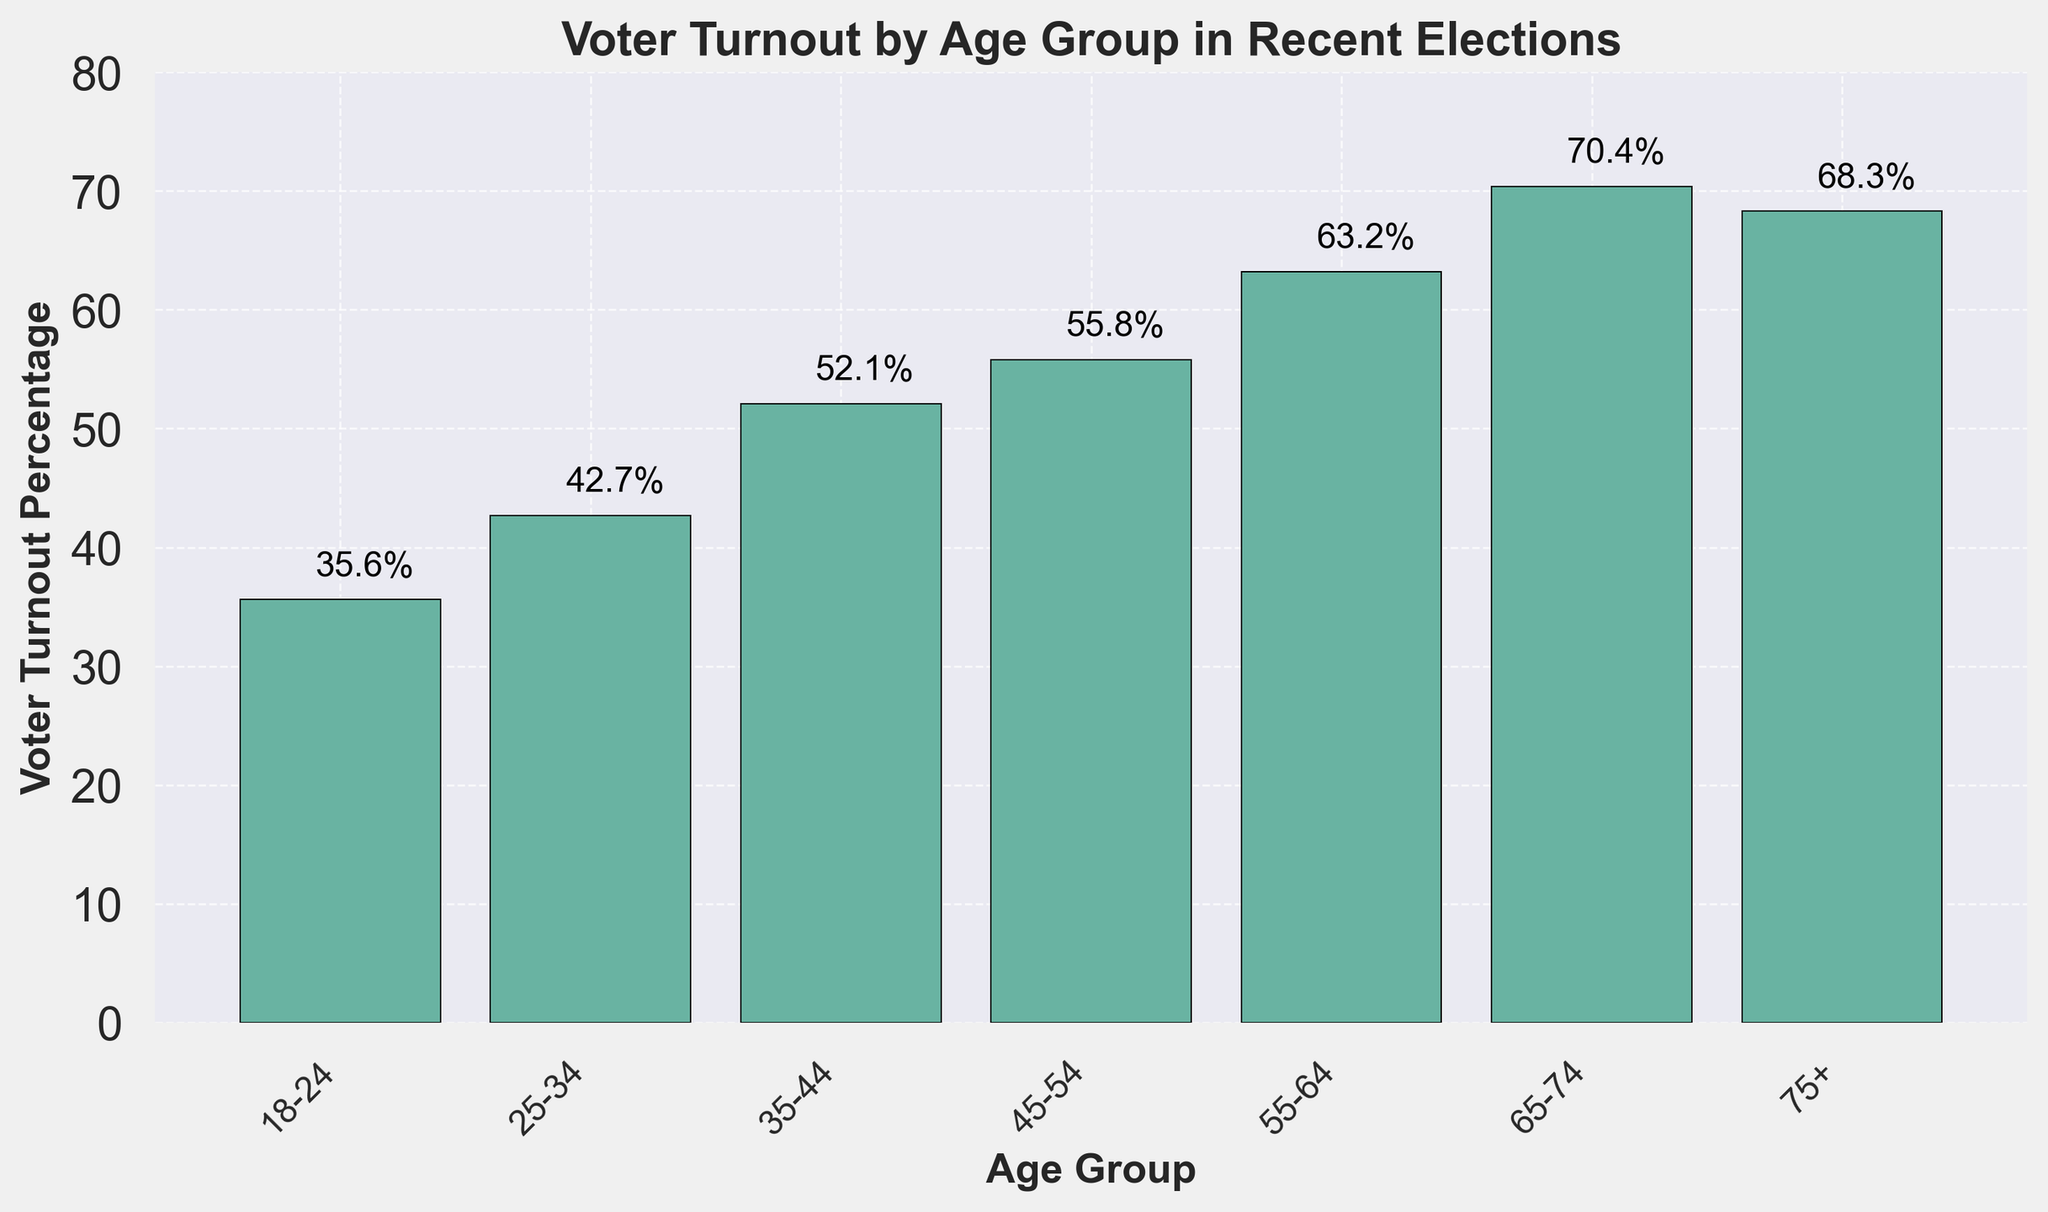What age group has the highest voter turnout percentage? The highest bar corresponds to the age group of 65-74, which reaches the highest point on the y-axis
Answer: 65-74 What is the difference in voter turnout between the age groups 55-64 and 25-34? Voter turnout for 55-64 is 63.2%, and for 25-34, it is 42.7%. Subtracting these gives 63.2% - 42.7% = 20.5%
Answer: 20.5% Which age group has the lowest voter turnout percentage? The shortest bar on the chart corresponds to the age group 18-24, which has the lowest point on the y-axis
Answer: 18-24 What is the average voter turnout percentage for the age groups under 45 years? Age groups under 45 include 18-24, 25-34, and 35-44. Their turnout percentages are 35.6%, 42.7%, and 52.1%. The average is (35.6 + 42.7 + 52.1) / 3 ≈ 43.47%
Answer: 43.47% How does the voter turnout of the age group 75+ compare to the 65-74 age group? The turnout for 75+ is 68.3%, and for 65-74 it's 70.4%. Thus, 75+ has a slightly lesser turnout than 65-74
Answer: Less turnout Which age group shows a voter turnout percentage closest to 50%? The age group 35-44 has a voter turnout of 52.1%, which is closest to 50% compared to other age groups
Answer: 35-44 What is the combined voter turnout percentage for age groups 55-64 and 65-74? For 55-64, the turnout is 63.2%, and for 65-74, it is 70.4%. Their combined turnout is 63.2% + 70.4% = 133.6%
Answer: 133.6% What is the voter turnout percentage for the age group 45-54? According to the histogram, the bar associated with the age group 45-54 reaches up to 55.8% on the y-axis
Answer: 55.8% What is the range of voter turnout percentages in the histogram? The lowest voter turnout is 35.6% (18-24), and the highest is 70.4% (65-74). The range is 70.4% - 35.6% = 34.8%
Answer: 34.8% Are there any age groups with equal voter turnout percentages? The chart shows that each age group has a unique voter turnout percentage, indicated by different heights of the bars
Answer: No 